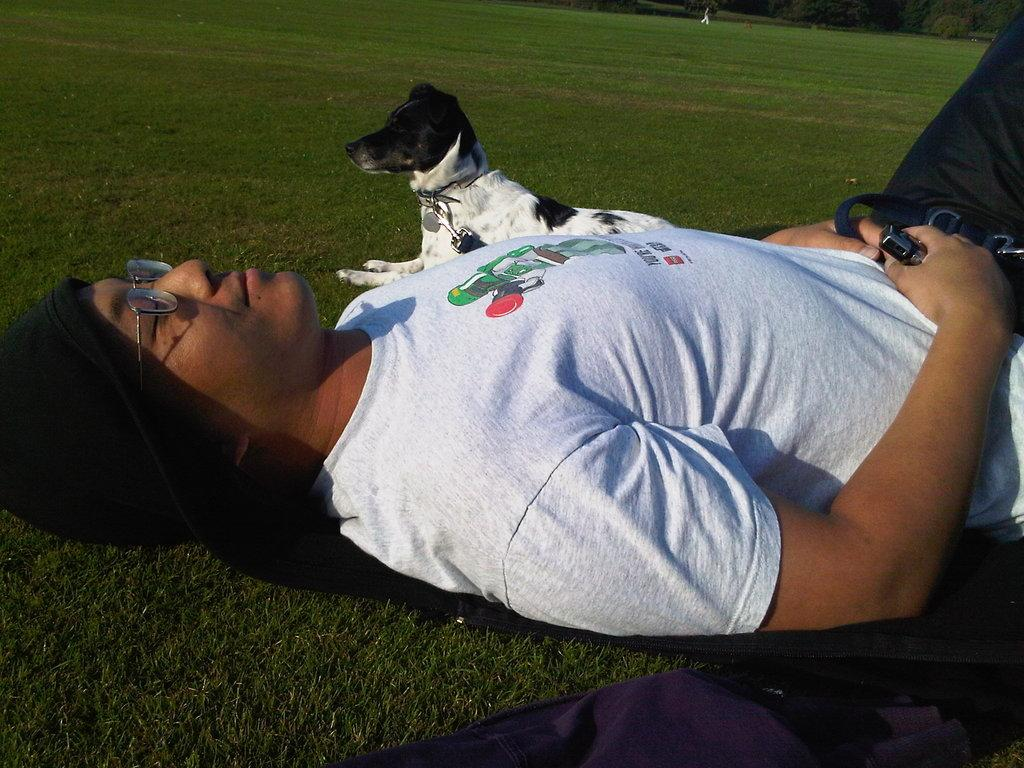What is the person in the image doing? The person is lying on the grass. What accessories is the person wearing? The person is wearing spectacles and a cap. Is there any other living creature in the image? Yes, there is a dog beside the person. What type of beds can be seen in the image? There are no beds present in the image. What kind of business is the person conducting in the image? The image does not depict any business activities; the person is simply lying on the grass with a dog beside them. 